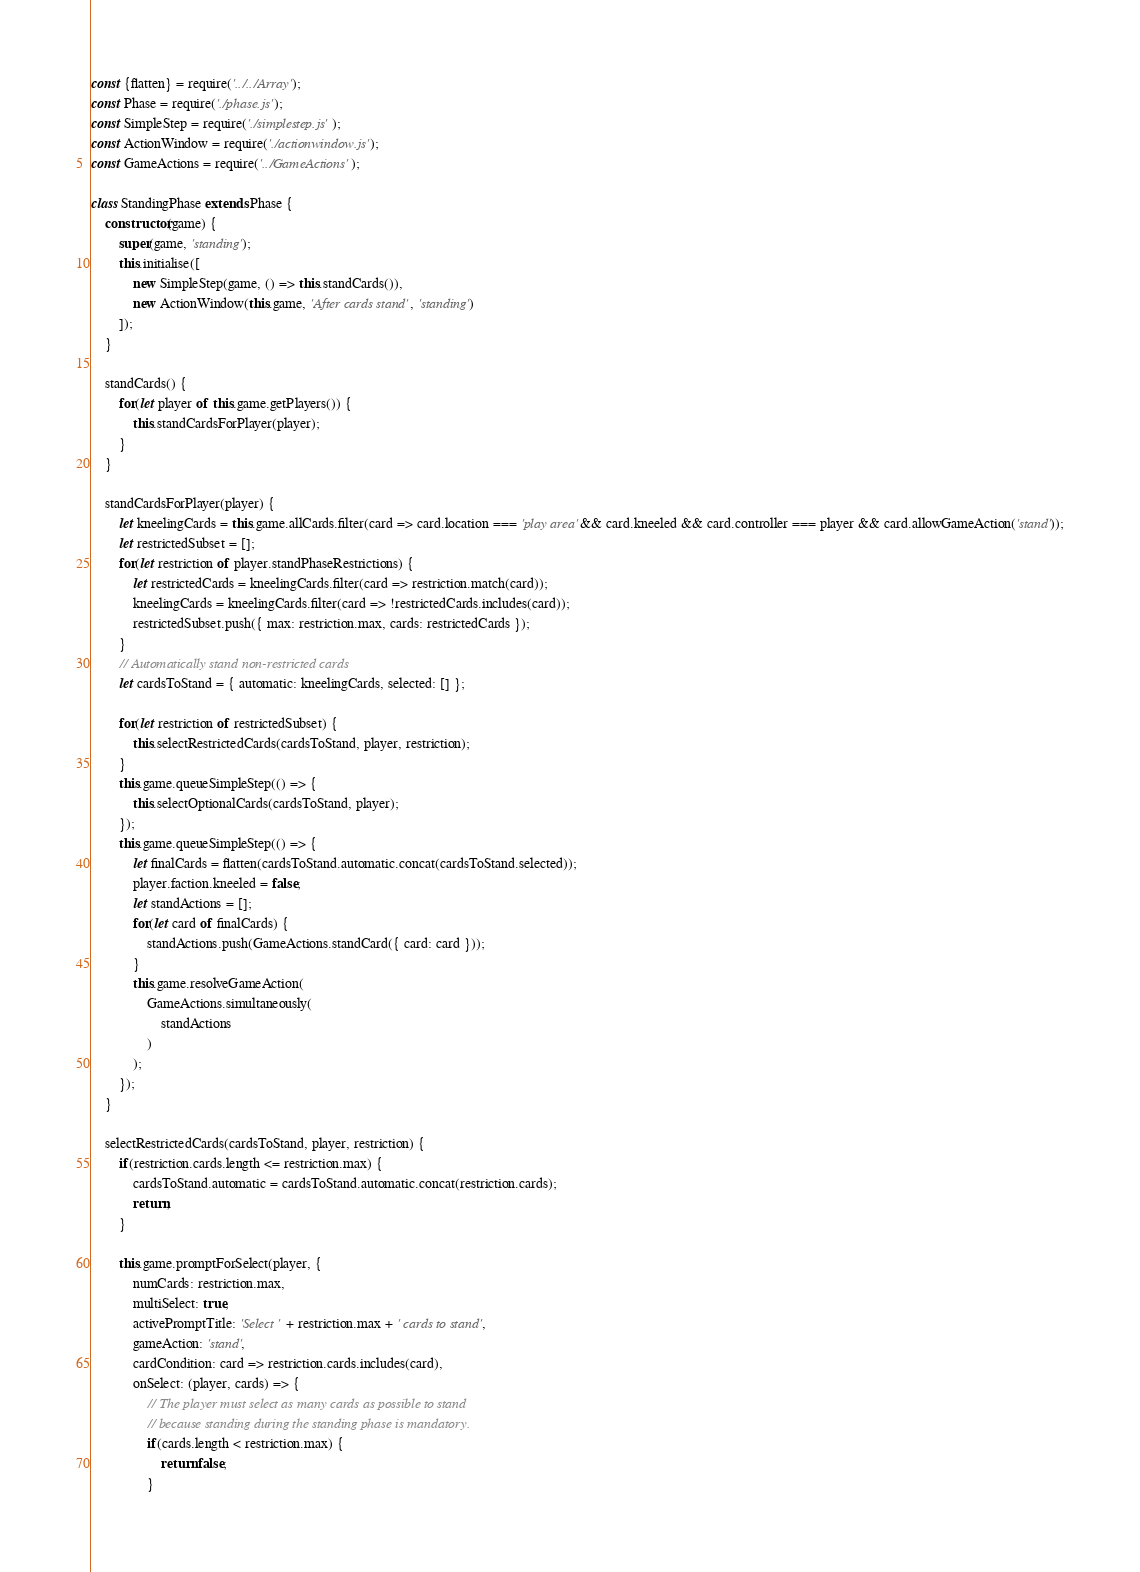<code> <loc_0><loc_0><loc_500><loc_500><_JavaScript_>const {flatten} = require('../../Array');
const Phase = require('./phase.js');
const SimpleStep = require('./simplestep.js');
const ActionWindow = require('./actionwindow.js');
const GameActions = require('../GameActions');

class StandingPhase extends Phase {
    constructor(game) {
        super(game, 'standing');
        this.initialise([
            new SimpleStep(game, () => this.standCards()),
            new ActionWindow(this.game, 'After cards stand', 'standing')
        ]);
    }

    standCards() {
        for(let player of this.game.getPlayers()) {
            this.standCardsForPlayer(player);
        }
    }

    standCardsForPlayer(player) {
        let kneelingCards = this.game.allCards.filter(card => card.location === 'play area' && card.kneeled && card.controller === player && card.allowGameAction('stand'));
        let restrictedSubset = [];
        for(let restriction of player.standPhaseRestrictions) {
            let restrictedCards = kneelingCards.filter(card => restriction.match(card));
            kneelingCards = kneelingCards.filter(card => !restrictedCards.includes(card));
            restrictedSubset.push({ max: restriction.max, cards: restrictedCards });
        }
        // Automatically stand non-restricted cards
        let cardsToStand = { automatic: kneelingCards, selected: [] };

        for(let restriction of restrictedSubset) {
            this.selectRestrictedCards(cardsToStand, player, restriction);
        }
        this.game.queueSimpleStep(() => {
            this.selectOptionalCards(cardsToStand, player);
        });
        this.game.queueSimpleStep(() => {
            let finalCards = flatten(cardsToStand.automatic.concat(cardsToStand.selected));
            player.faction.kneeled = false;
            let standActions = [];
            for(let card of finalCards) {
                standActions.push(GameActions.standCard({ card: card }));
            }
            this.game.resolveGameAction(
                GameActions.simultaneously(
                    standActions
                )
            );
        });
    }

    selectRestrictedCards(cardsToStand, player, restriction) {
        if(restriction.cards.length <= restriction.max) {
            cardsToStand.automatic = cardsToStand.automatic.concat(restriction.cards);
            return;
        }

        this.game.promptForSelect(player, {
            numCards: restriction.max,
            multiSelect: true,
            activePromptTitle: 'Select ' + restriction.max + ' cards to stand',
            gameAction: 'stand',
            cardCondition: card => restriction.cards.includes(card),
            onSelect: (player, cards) => {
                // The player must select as many cards as possible to stand
                // because standing during the standing phase is mandatory.
                if(cards.length < restriction.max) {
                    return false;
                }
</code> 